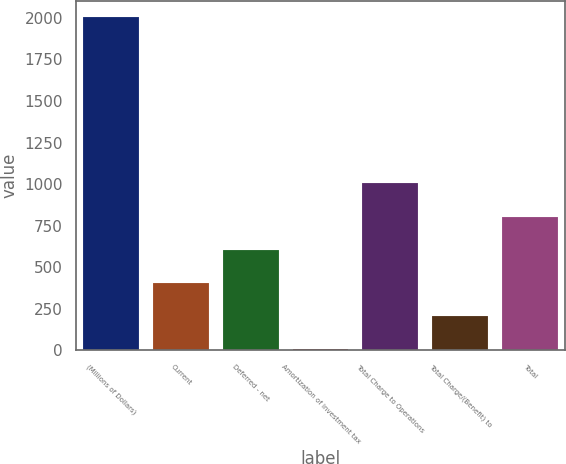<chart> <loc_0><loc_0><loc_500><loc_500><bar_chart><fcel>(Millions of Dollars)<fcel>Current<fcel>Deferred - net<fcel>Amortization of investment tax<fcel>Total Charge to Operations<fcel>Total Charge/(Benefit) to<fcel>Total<nl><fcel>2003<fcel>405.4<fcel>605.1<fcel>6<fcel>1004.5<fcel>205.7<fcel>804.8<nl></chart> 